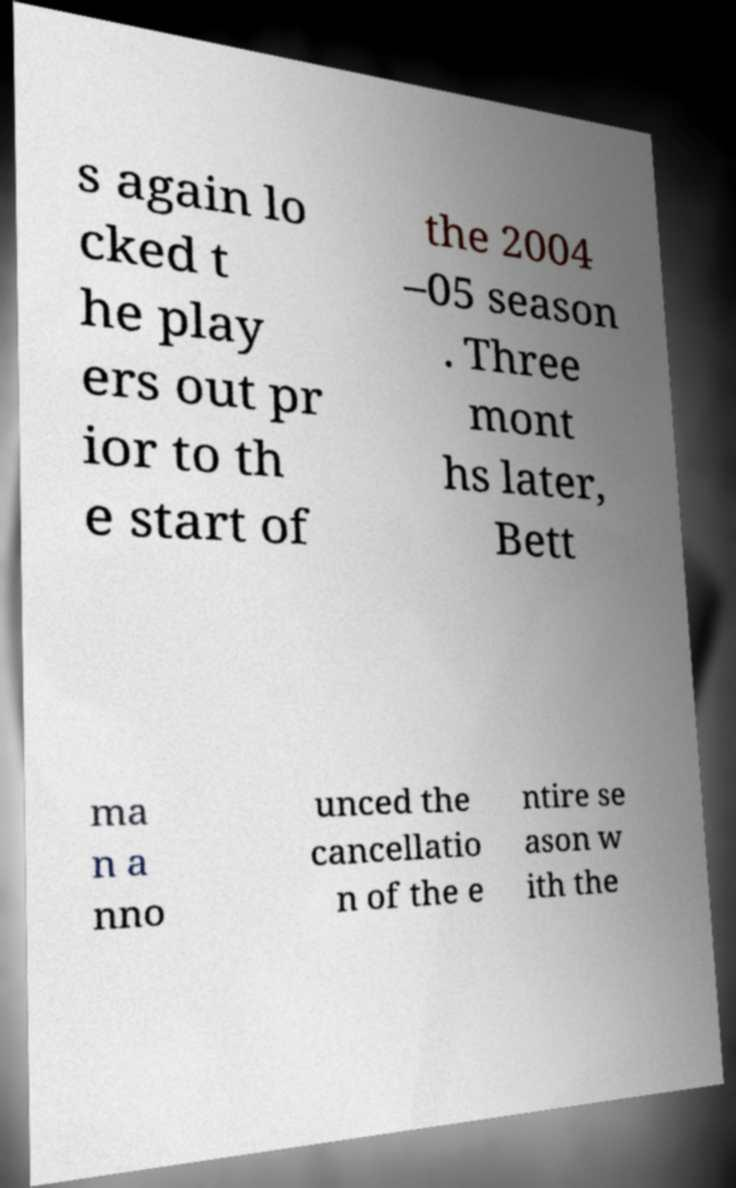There's text embedded in this image that I need extracted. Can you transcribe it verbatim? s again lo cked t he play ers out pr ior to th e start of the 2004 –05 season . Three mont hs later, Bett ma n a nno unced the cancellatio n of the e ntire se ason w ith the 